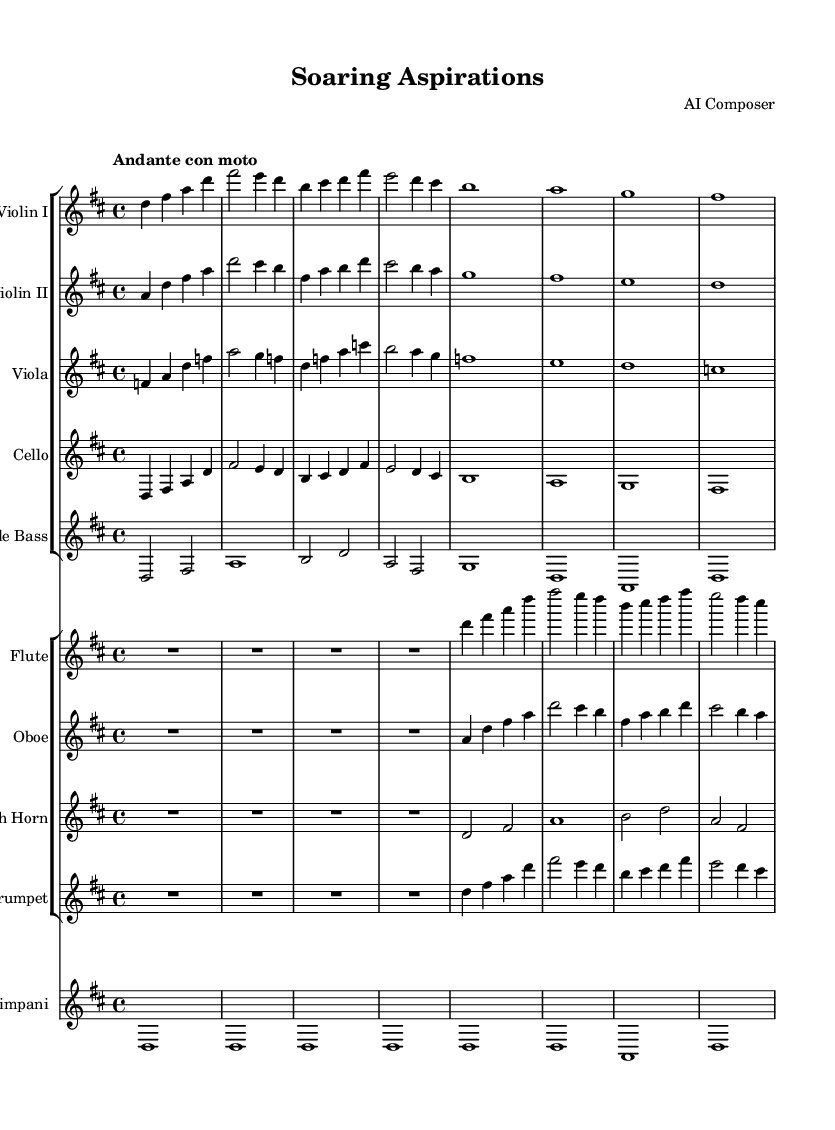What is the key signature of this music? The key signature is D major, which has two sharps (F# and C#). You can determine this by looking at the key signature marked at the beginning of the staff.
Answer: D major What is the time signature of this piece? The time signature is 4/4, which indicates that there are four beats in each measure and the quarter note gets one beat. This is visible at the start where the time signature is indicated.
Answer: 4/4 What is the tempo marking of the music? The tempo marking is "Andante con moto," which indicates a moderately slow tempo with a bit of forward motion. This can be found in the tempo indication at the beginning of the score.
Answer: Andante con moto How many measures are in the first line of the piece? There are four measures in the first line. This can be counted by looking at the measures that are separated by vertical bar lines.
Answer: 4 Which instruments have the same rhythm in the first measure? The Flute, Violin I, and Violin II all play the same rhythm in the first measure, which is evident by comparing the note durations and placements in the first measure.
Answer: Flute, Violin I, Violin II What note is the last note of the cello part? The last note of the cello part is F#. To find this, you can look at the last measure of the cello staff and identify the note being played.
Answer: F# What is the dynamic marking for the timpani part? There is no specific dynamic marking for the timpani part in the provided score, which means it follows the default dynamic levels unless otherwise indicated.
Answer: None 